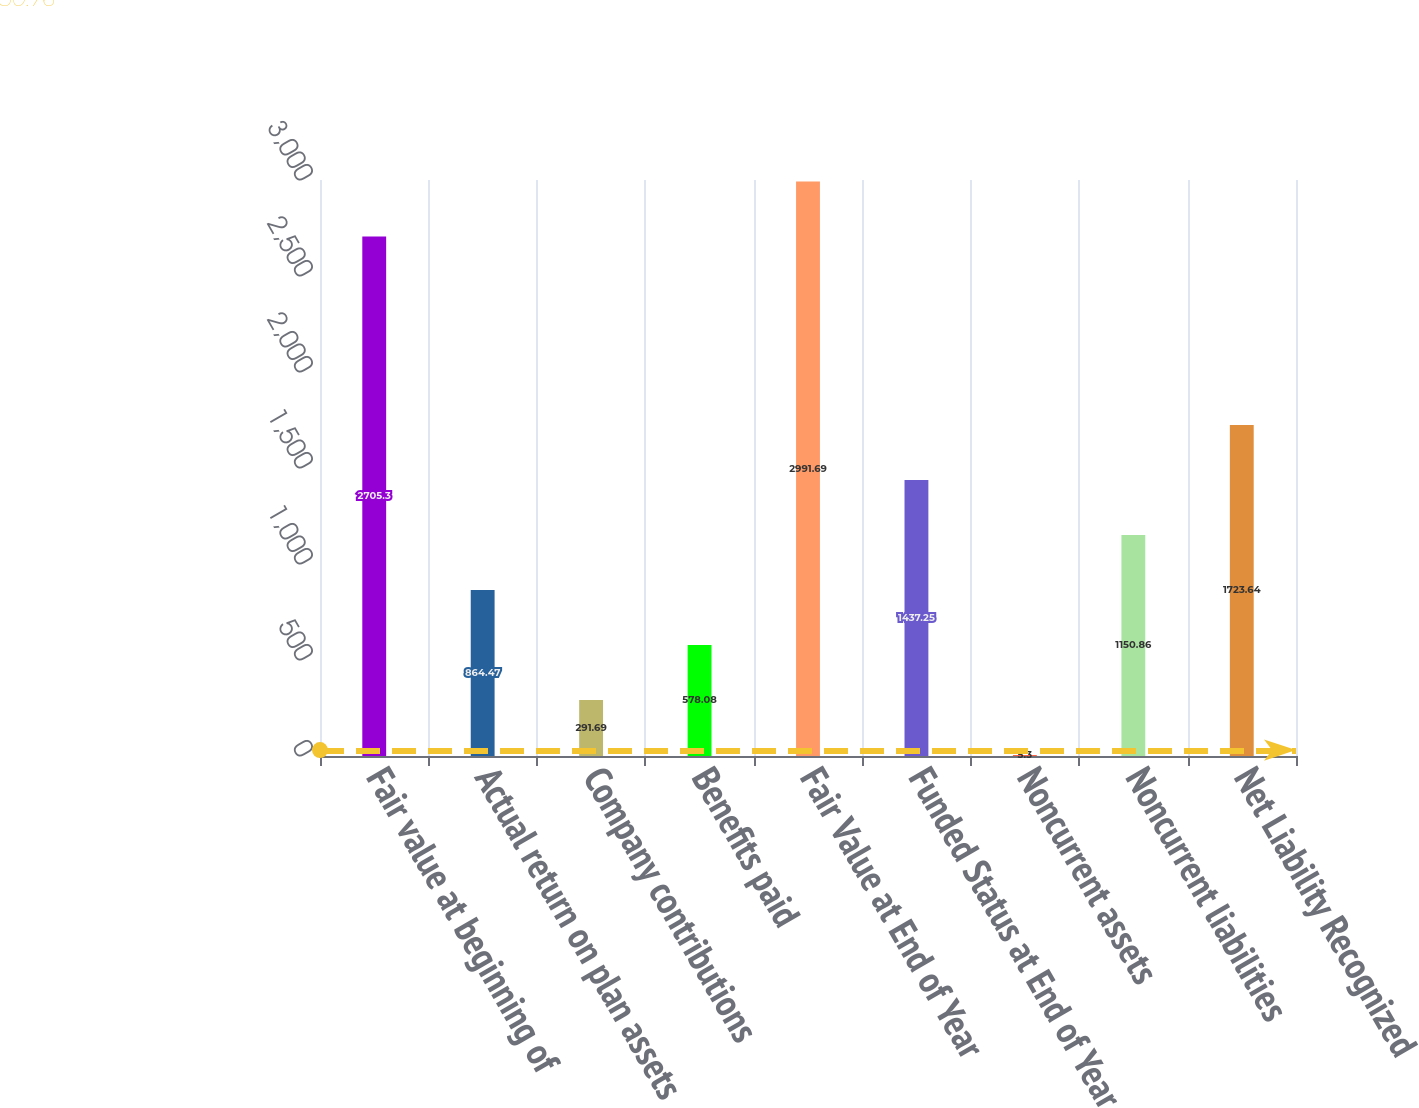Convert chart to OTSL. <chart><loc_0><loc_0><loc_500><loc_500><bar_chart><fcel>Fair value at beginning of<fcel>Actual return on plan assets<fcel>Company contributions<fcel>Benefits paid<fcel>Fair Value at End of Year<fcel>Funded Status at End of Year<fcel>Noncurrent assets<fcel>Noncurrent liabilities<fcel>Net Liability Recognized<nl><fcel>2705.3<fcel>864.47<fcel>291.69<fcel>578.08<fcel>2991.69<fcel>1437.25<fcel>5.3<fcel>1150.86<fcel>1723.64<nl></chart> 